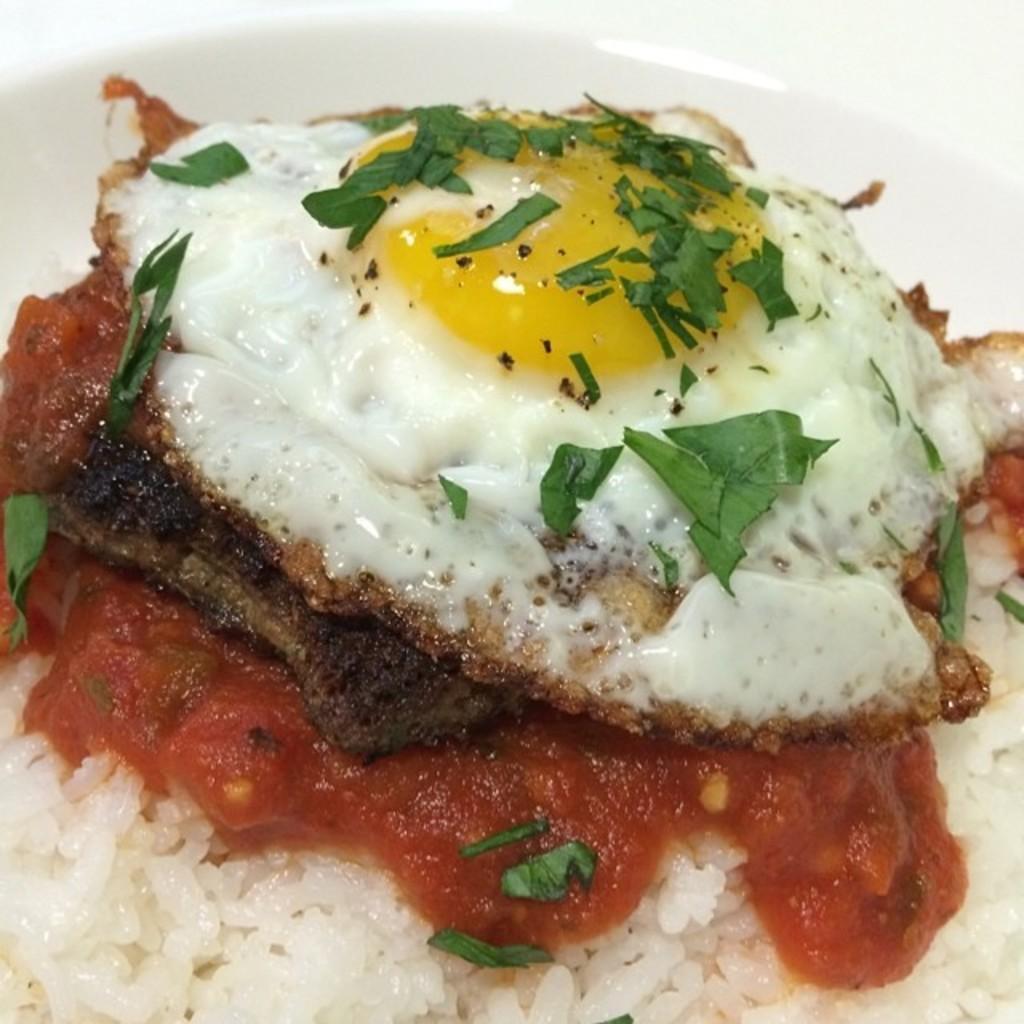In one or two sentences, can you explain what this image depicts? In this picture there is a rice, omelet and leafy vegetables in the bowl and the bowl is in white color. 